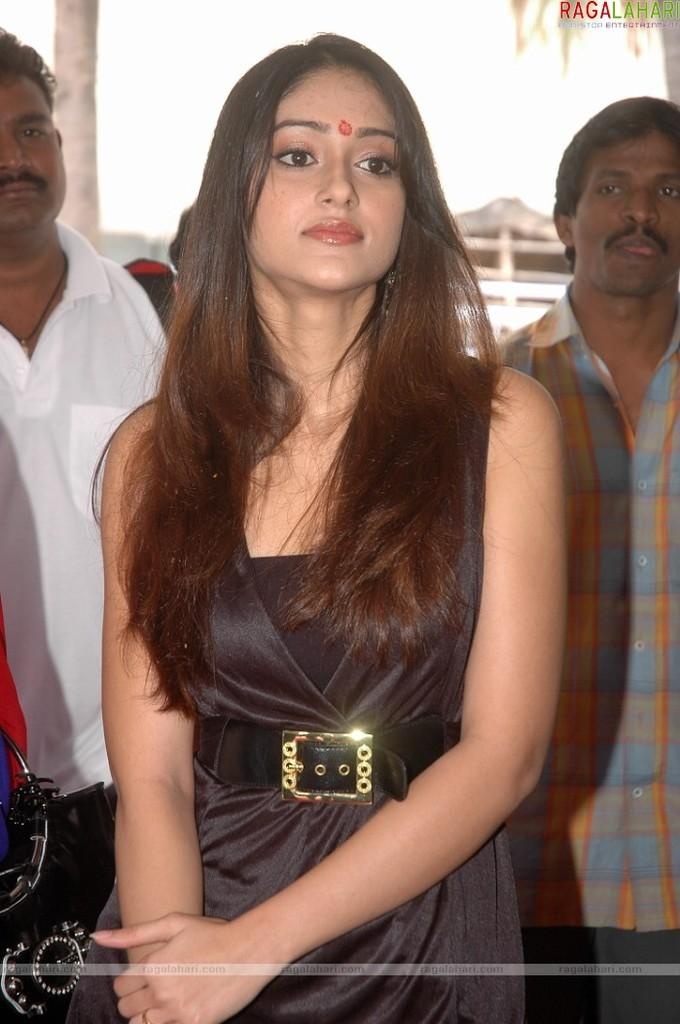What is the main subject of the image? There is a woman standing in the image. Are there any other people in the image? Yes, there are two other persons standing in the image. Can you describe the background of the image? The background of the image is blurred. Are there any visible marks or features on the image itself? Yes, there are watermarks on the image. What type of earth can be seen in the image? There is no earth visible in the image; it is a photograph of people standing. Are the two other persons in the image sisters? The provided facts do not mention any familial relationship between the two other persons in the image. 